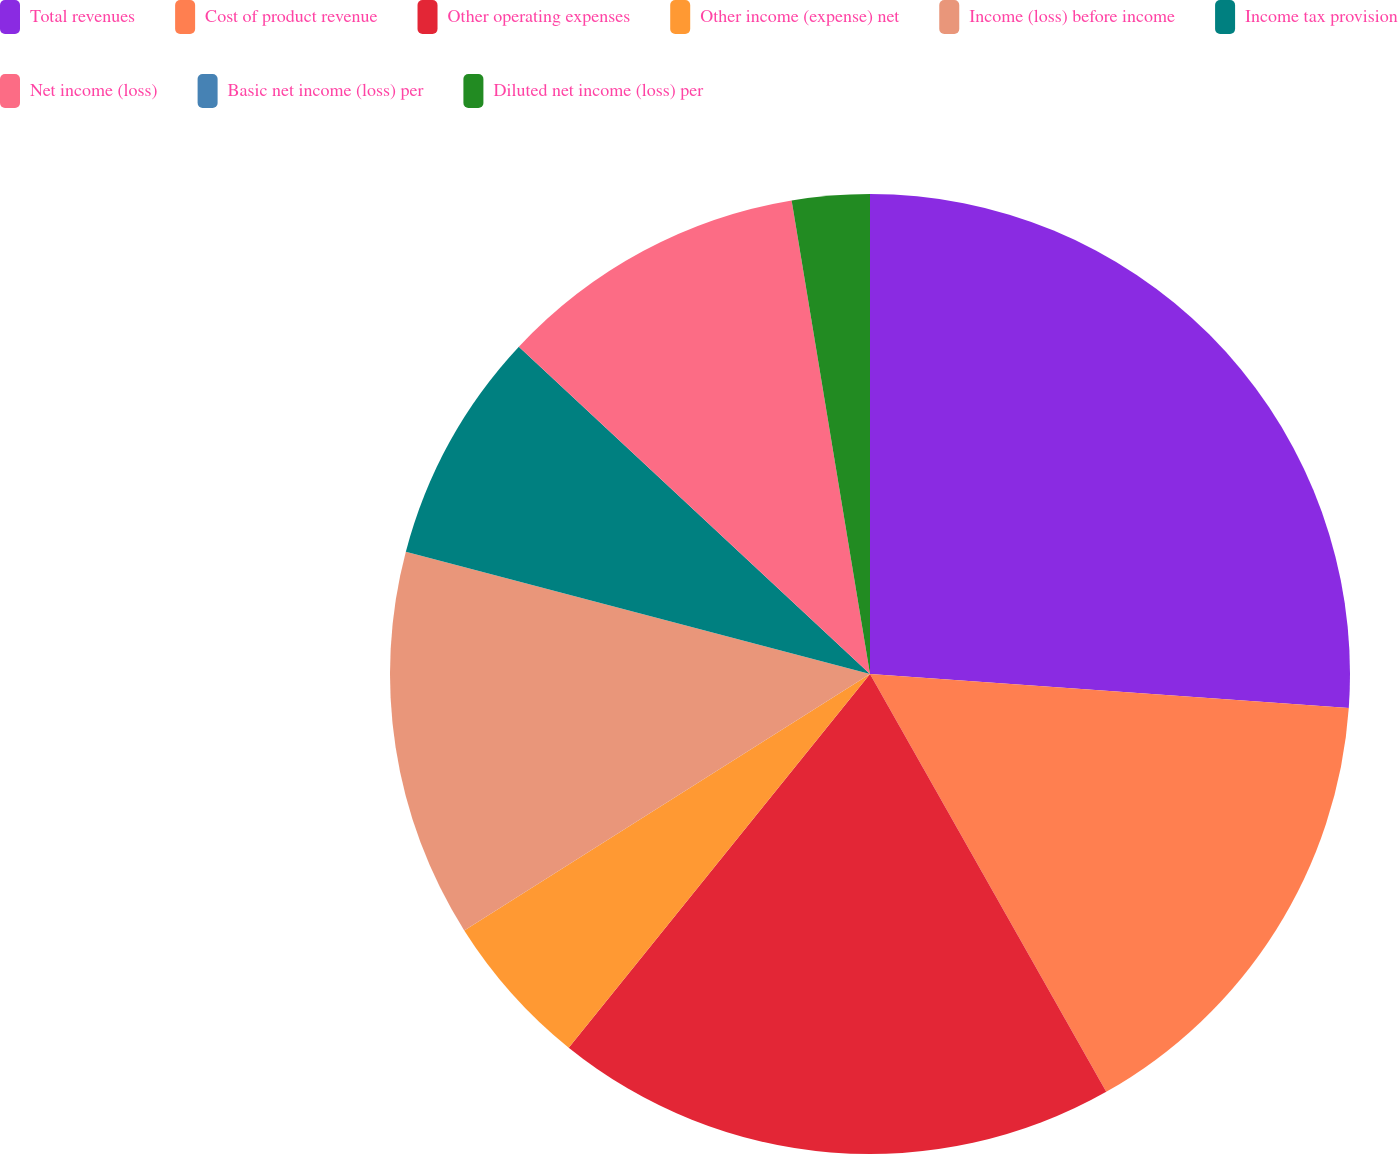Convert chart to OTSL. <chart><loc_0><loc_0><loc_500><loc_500><pie_chart><fcel>Total revenues<fcel>Cost of product revenue<fcel>Other operating expenses<fcel>Other income (expense) net<fcel>Income (loss) before income<fcel>Income tax provision<fcel>Net income (loss)<fcel>Basic net income (loss) per<fcel>Diluted net income (loss) per<nl><fcel>26.13%<fcel>15.68%<fcel>18.99%<fcel>5.23%<fcel>13.07%<fcel>7.84%<fcel>10.45%<fcel>0.0%<fcel>2.61%<nl></chart> 